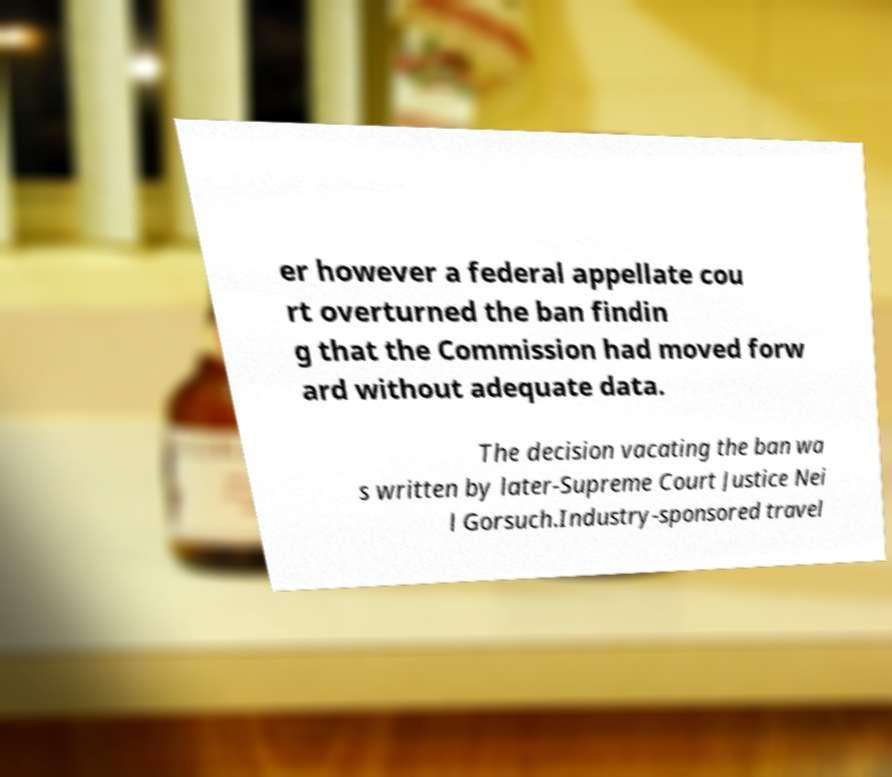Please read and relay the text visible in this image. What does it say? er however a federal appellate cou rt overturned the ban findin g that the Commission had moved forw ard without adequate data. The decision vacating the ban wa s written by later-Supreme Court Justice Nei l Gorsuch.Industry-sponsored travel 